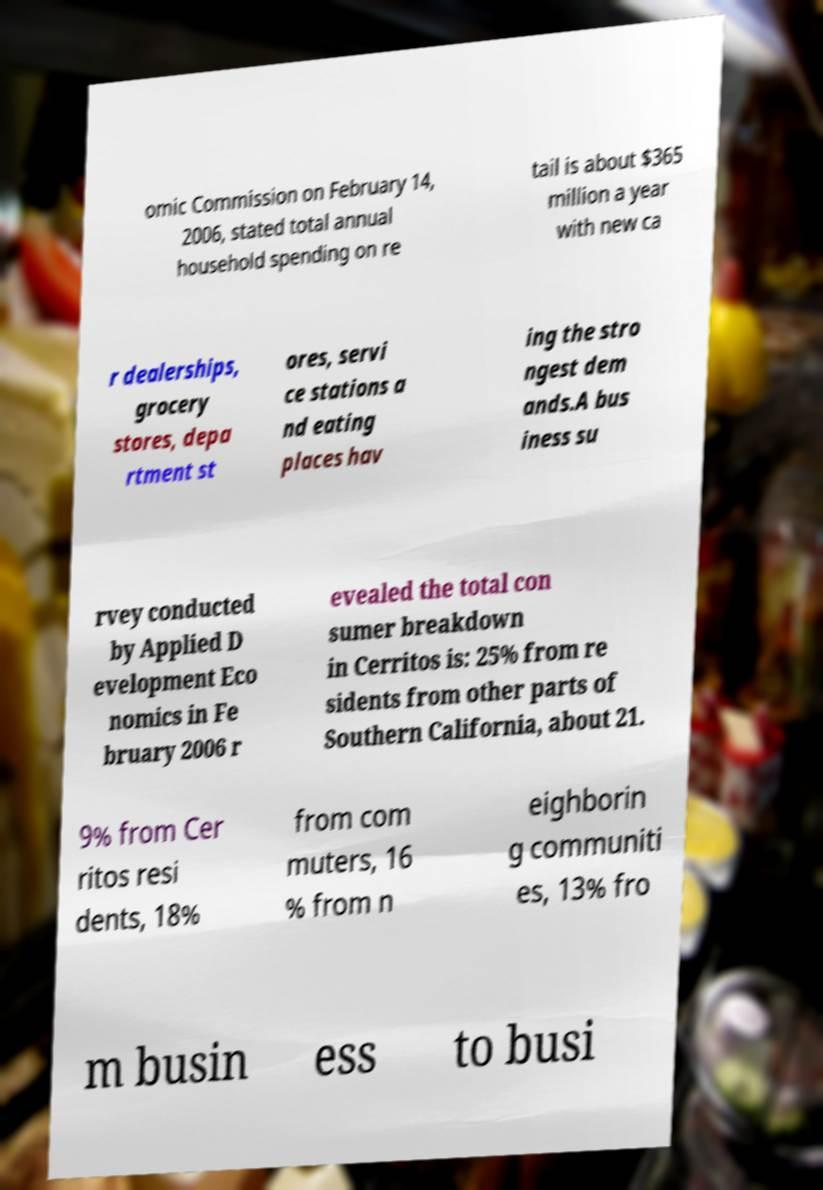Could you extract and type out the text from this image? omic Commission on February 14, 2006, stated total annual household spending on re tail is about $365 million a year with new ca r dealerships, grocery stores, depa rtment st ores, servi ce stations a nd eating places hav ing the stro ngest dem ands.A bus iness su rvey conducted by Applied D evelopment Eco nomics in Fe bruary 2006 r evealed the total con sumer breakdown in Cerritos is: 25% from re sidents from other parts of Southern California, about 21. 9% from Cer ritos resi dents, 18% from com muters, 16 % from n eighborin g communiti es, 13% fro m busin ess to busi 